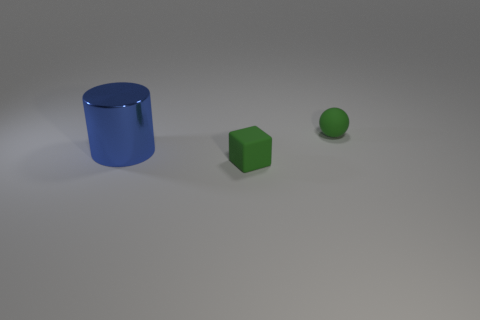Subtract all blocks. How many objects are left? 2 Add 3 green rubber objects. How many objects exist? 6 Subtract 0 brown cylinders. How many objects are left? 3 Subtract all cyan cylinders. Subtract all yellow blocks. How many cylinders are left? 1 Subtract all tiny rubber objects. Subtract all big cylinders. How many objects are left? 0 Add 1 small matte balls. How many small matte balls are left? 2 Add 3 cylinders. How many cylinders exist? 4 